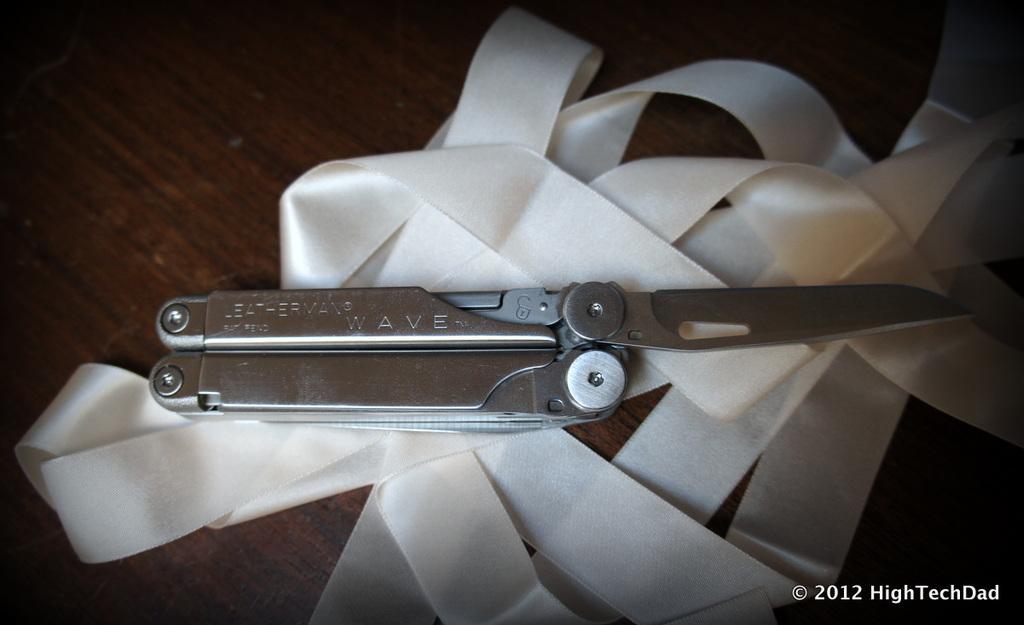Can you describe this image briefly? In this image there is a knife and a ribbon on the table, at the bottom of the image there is some text. 